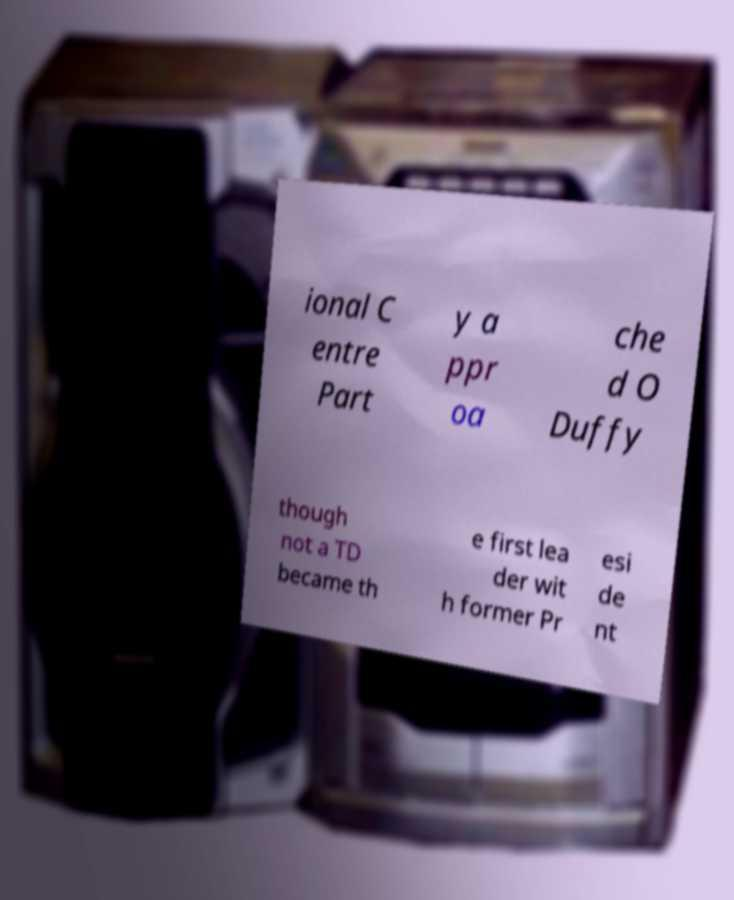Could you extract and type out the text from this image? ional C entre Part y a ppr oa che d O Duffy though not a TD became th e first lea der wit h former Pr esi de nt 